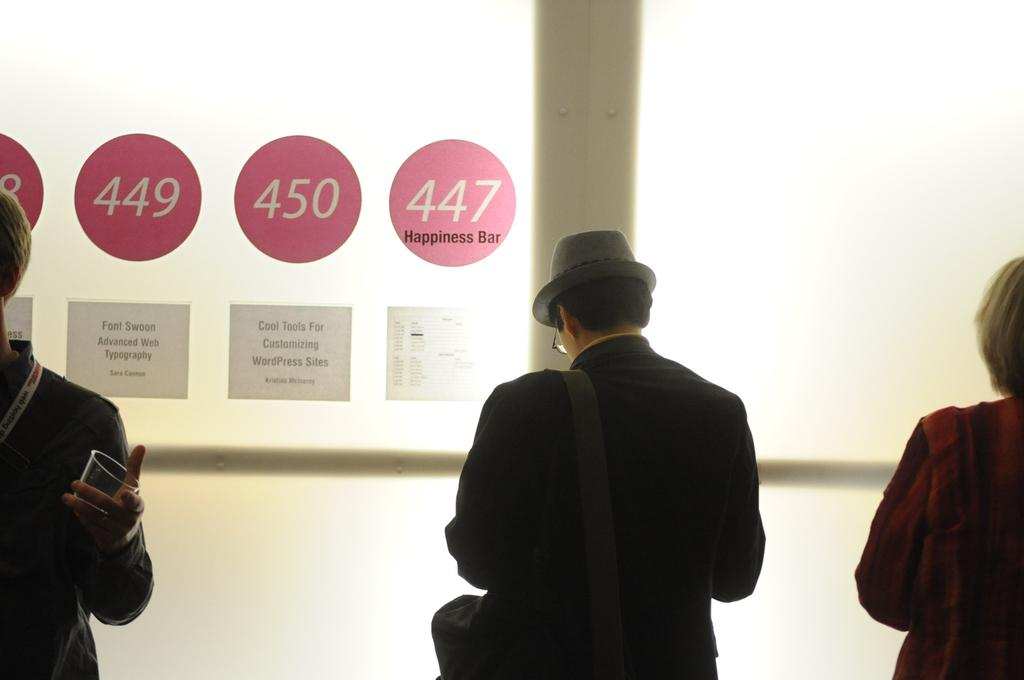How many people are present in the image? There are three persons standing in the image. What can be seen in the background of the image? There are papers attached to a glass wall and poles visible in the background. What is the size of the heart-shaped balloon in the image? There is no heart-shaped balloon present in the image. 